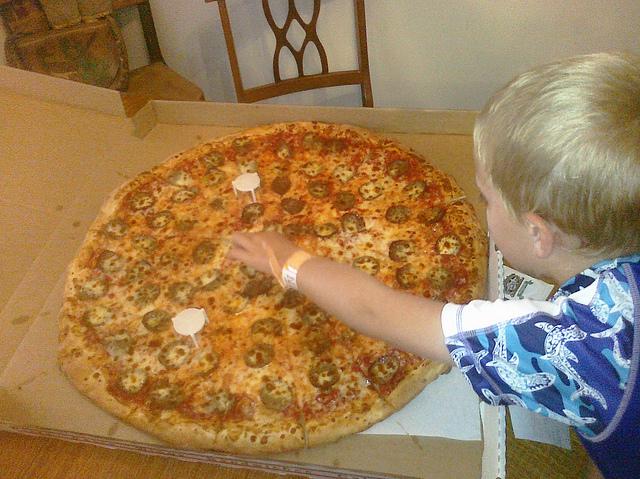Can this boy eat this pizza alone?
Short answer required. No. Is the pizza already sliced?
Quick response, please. Yes. What topping is the boy picking off of the pizza?
Give a very brief answer. Peppers. 